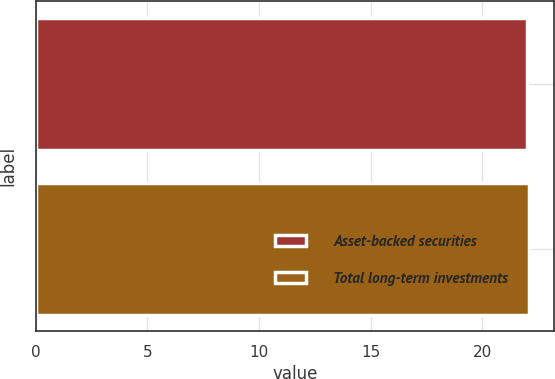Convert chart to OTSL. <chart><loc_0><loc_0><loc_500><loc_500><bar_chart><fcel>Asset-backed securities<fcel>Total long-term investments<nl><fcel>22<fcel>22.1<nl></chart> 